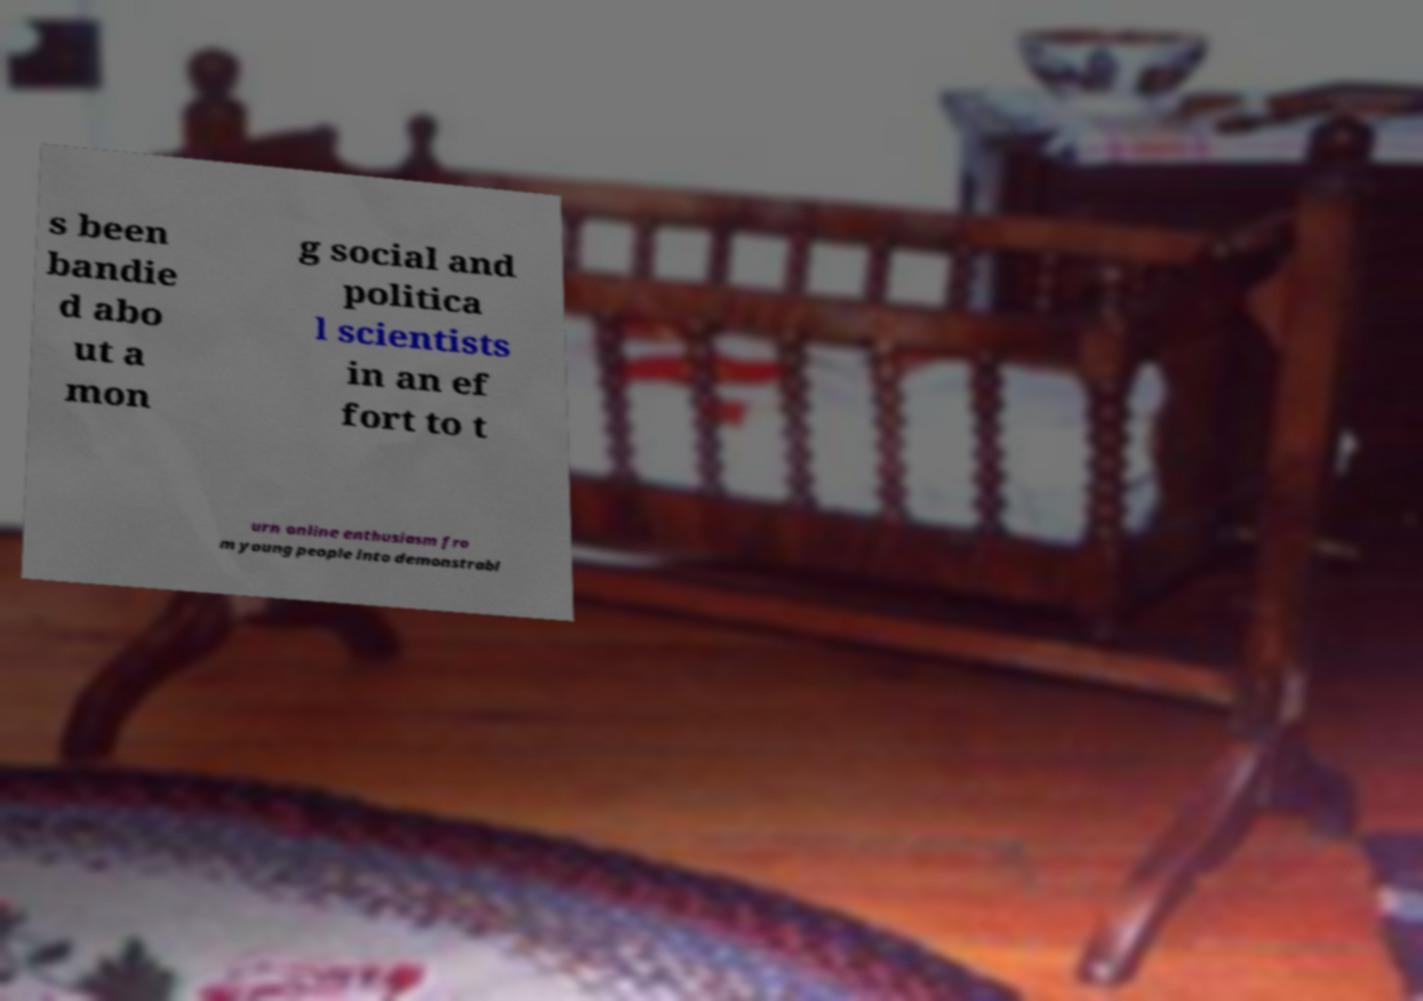Can you accurately transcribe the text from the provided image for me? s been bandie d abo ut a mon g social and politica l scientists in an ef fort to t urn online enthusiasm fro m young people into demonstrabl 